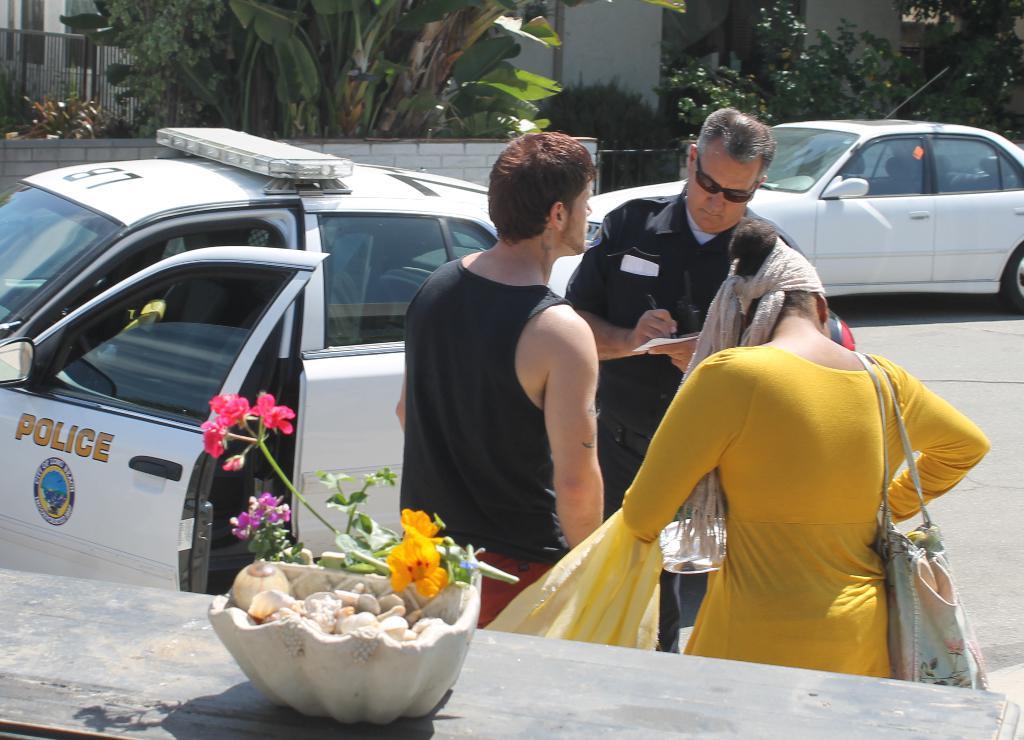What kind of car is seen here?
Offer a very short reply. Police. What number is on top of the police car?
Give a very brief answer. 87. 